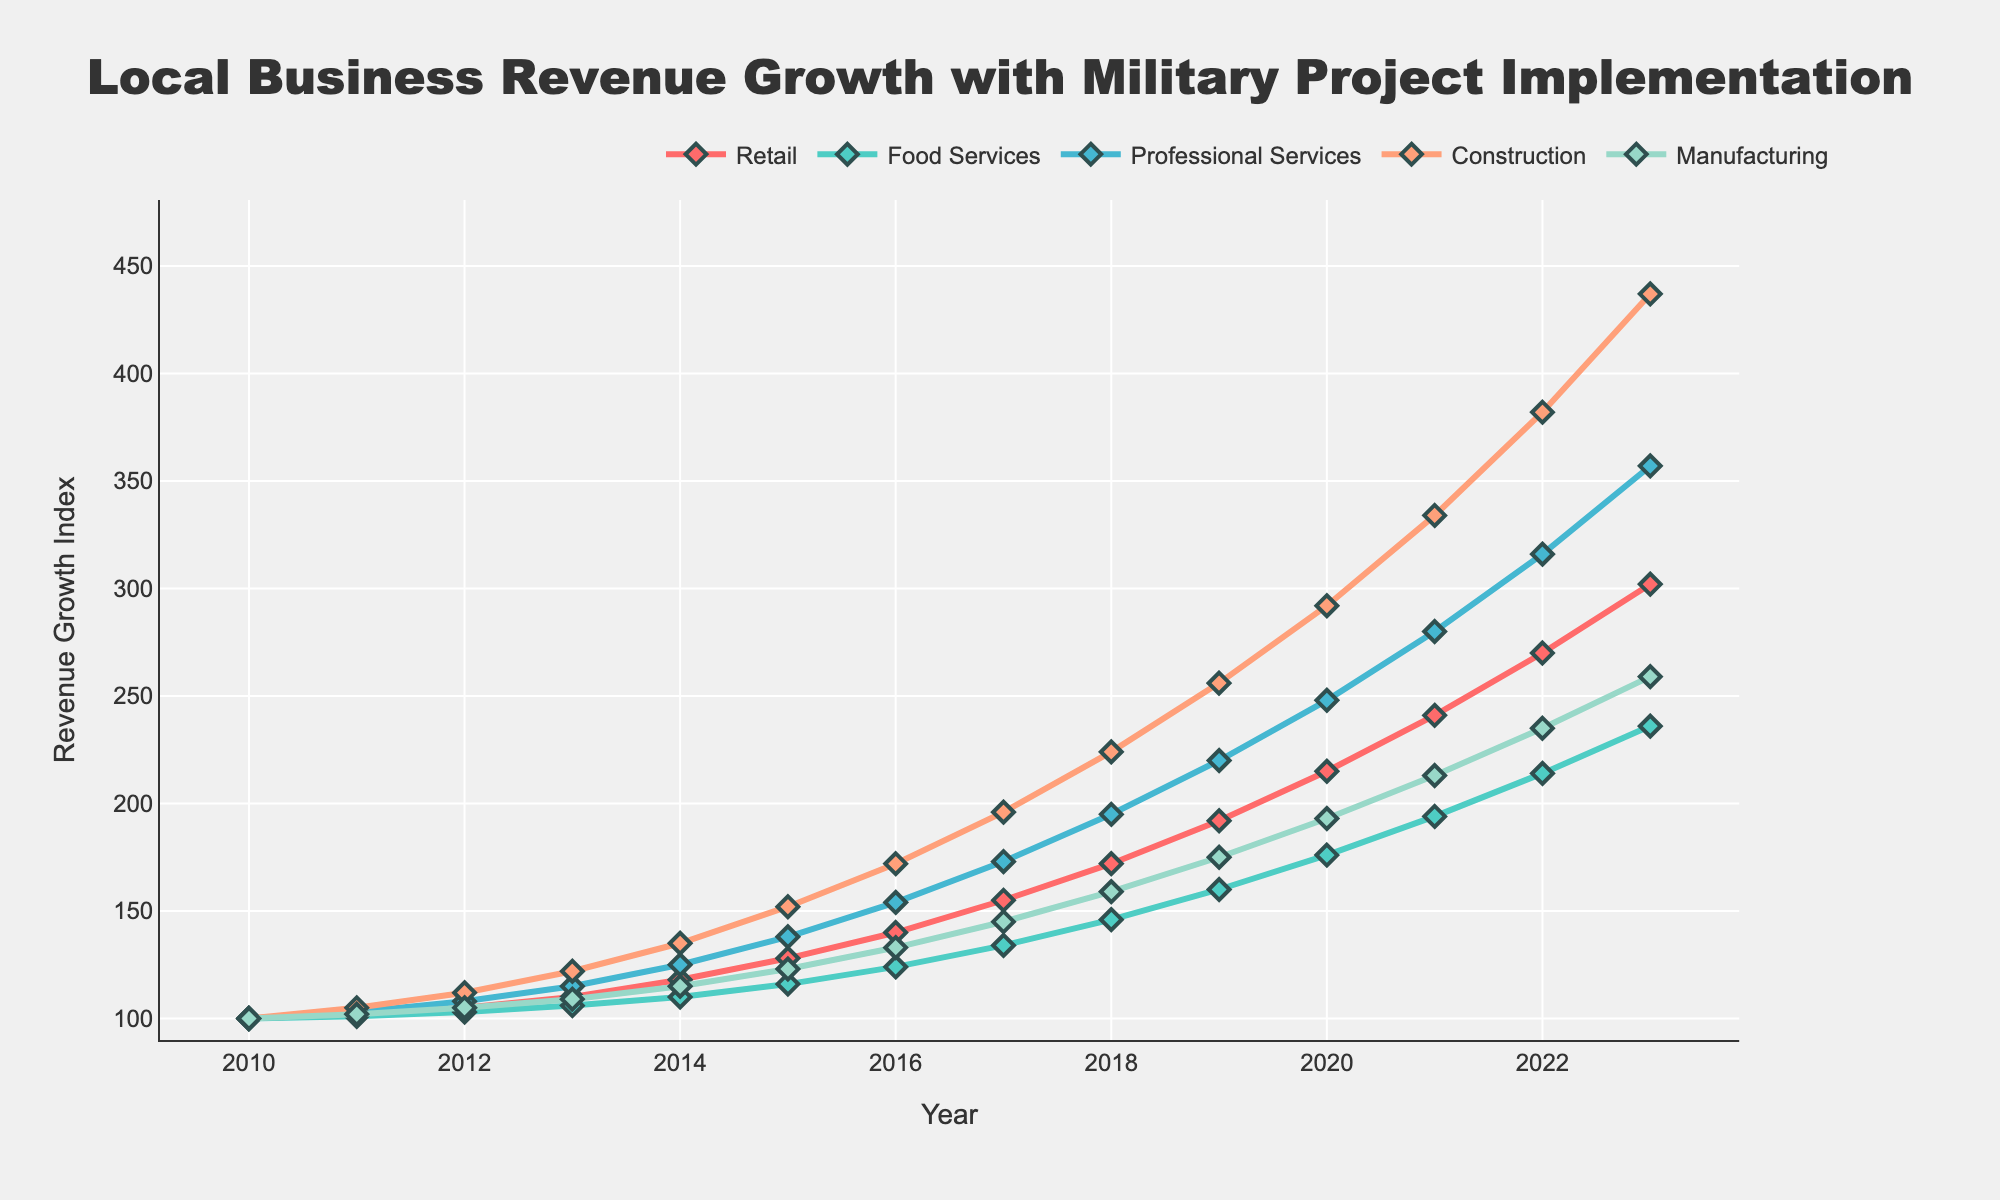Which business category shows the highest revenue growth in 2023? To determine the highest revenue growth, we observe the endpoints of each line on the graph for 2023. The Construction category's line has the highest endpoint.
Answer: Construction How much did the Manufacturing revenue index grow from 2010 to 2023? The Manufacturing revenue index started at 100 in 2010 and grew to 259 in 2023. The growth is 259 - 100 = 159.
Answer: 159 Compare the revenue growth trends of Retail and Food Services from 2010 to 2023. Which one grew faster? Observe the slope of the lines representing the Retail and Food Services categories. Retail has a steeper slope and ends higher in 2023 (302) compared to Food Services (236), indicating faster growth.
Answer: Retail What is the average revenue growth index of Professional Services from 2010 to 2023? To find the average, add the yearly revenue indices for Professional Services and divide by the number of years: (100 + 103 + 108 + 115 + 125 + 138 + 154 + 173 + 195 + 220 + 248 + 280 + 316 + 357) / 14.
Answer: 198.6 Which year saw the largest increase in the Construction revenue index? To find the largest increase year-over-year, compare the differences for each year. The largest increase occurs between 2022 and 2023: 437 - 382 = 55.
Answer: 2023 Is there any year where the Manufacturing growth rate seems to be stagnant compared to others? By examining the line for Manufacturing, the year 2011 to 2012 shows minimal growth (from 102 to 105, an increase of 3), indicating stagnation.
Answer: 2011-2012 How did the Food Services revenue growth compare to Professional Services in 2015? In the year 2015, check the endpoints of the lines representing Food Services (116) and Professional Services (138) to see which is higher. Professional Services shows greater growth.
Answer: Professional Services What is the difference in the revenue growth index of Retail from 2019 to 2023? The Retail index in 2019 is 192 and in 2023 is 302. The difference is 302 - 192 = 110.
Answer: 110 Among all categories, which shows the most consistent growth pattern over the years? The most consistent growth pattern can be observed by identifying the line with the most uniform slope and minimal fluctuations. Food Services seems to have a relatively steady growth pattern.
Answer: Food Services Which business category experienced the smallest growth from 2010 to 2012? Compare the growth indices from 2010 to 2012 for each category. Food Services grew from 100 to 103, a 3-point increase, which is the smallest among all categories.
Answer: Food Services 